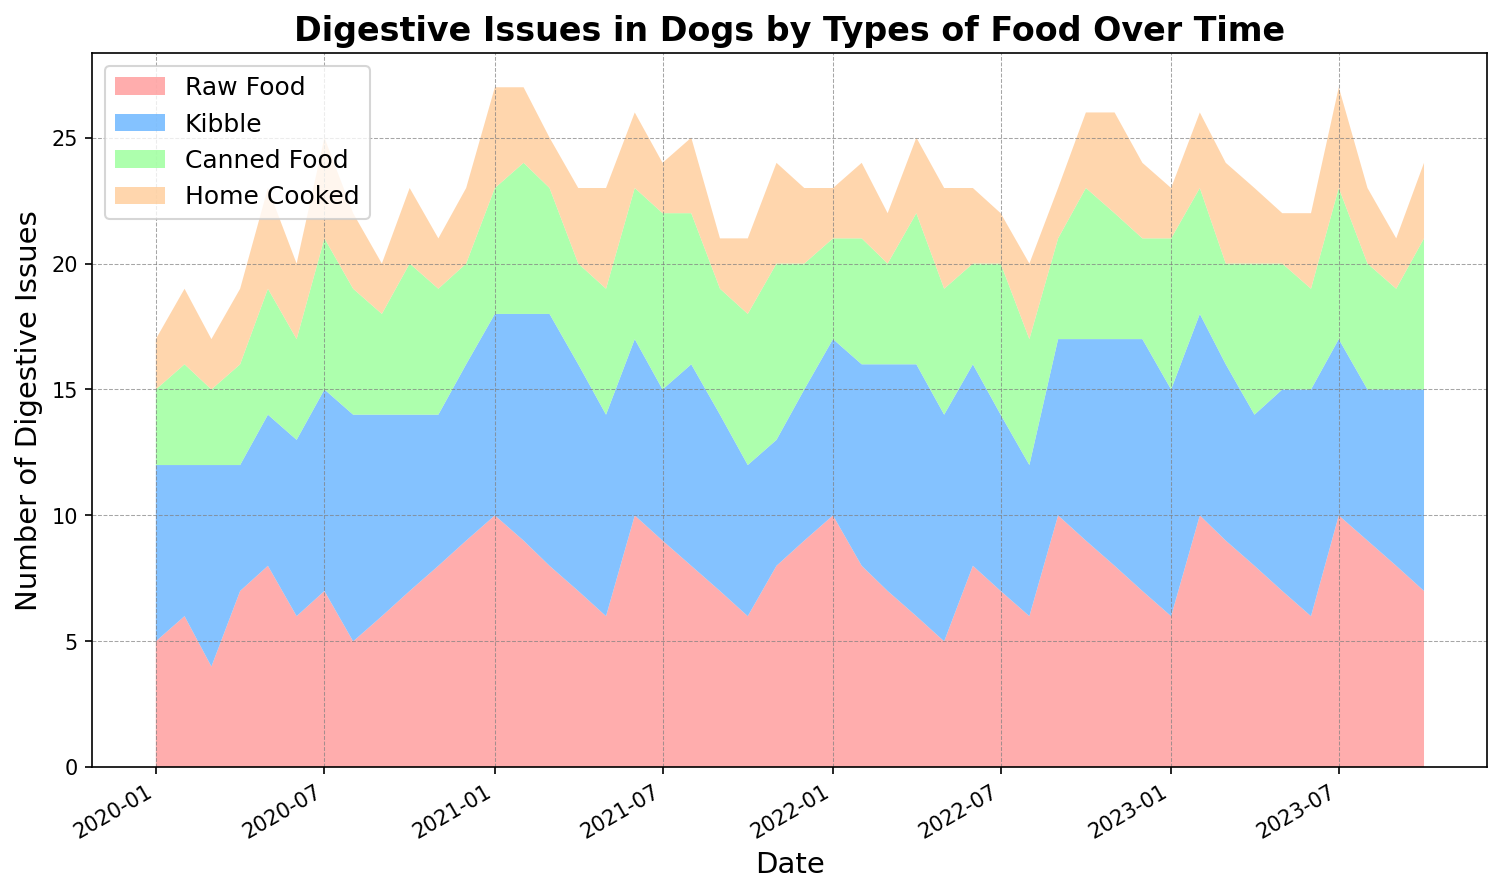what is the trend in digestive issues associated with raw food from January 2020 to October 2023? Starting from January 2020, the number of digestive issues associated with raw food generally increases, reaching a peak around January and June 2022, and then fluctuates slightly before peaking again in February 2023.
Answer: Increasing trend with fluctuations how does the digestive issue count for kibble in October 2021 compare to that in October 2023? In October 2021, the count for kibble is 6, whereas in October 2023, it is 8.
Answer: It increased from 6 to 8 which type of food had the highest number of digestive issues in July 2021? By visual inspection, the highest band in July 2021 corresponds to kibble, which looks higher than raw food, canned food, and home cooked.
Answer: kibble what is the sum of digestive issues for canned food and home cooked food in December 2022? In December 2022, canned food had 4 issues, and home cooked had 3. Summing these gives 4 + 3 = 7.
Answer: 7 did digestive issues related to home cooked food ever surpass those related to raw food in the given timeframe? Throughout the chart, the band representing home cooked food never surpasses the band for raw food, indicating that digestive issues for home cooked food remain consistently lower than those for raw food.
Answer: No what is the overall pattern for digestive issues associated with home cooked food? Digestive issues related to home cooked food show slight fluctuations but generally remain low and relatively stable throughout the period compared to other food types.
Answer: Relatively stable and low how did the number of digestive issues for kibble change between March 2021 and June 2021? In March 2021, the count for kibble was 10, and it decreased to 7 by June 2021.
Answer: Decreased from 10 to 7 when was the maximum number of digestive issues recorded for raw food, and what was that number? The maximum number of digestive issues for raw food was recorded in June 2021 and January 2022, with a count of 10 in both instances.
Answer: June 2021 and January 2022, 10 is there a specific time period where all food types showed an increasing trend in digestive issues? Around late 2021, most food types (kibble, canned food, raw food, and home cooked) show an increasing trend in digestive issues, particularly in the second half of 2021.
Answer: Late 2021 during which month did canned food display the least number of digestive issues? Canned food displayed the least number of digestive issues in March 2023 with a count of 2.
Answer: March 2023 